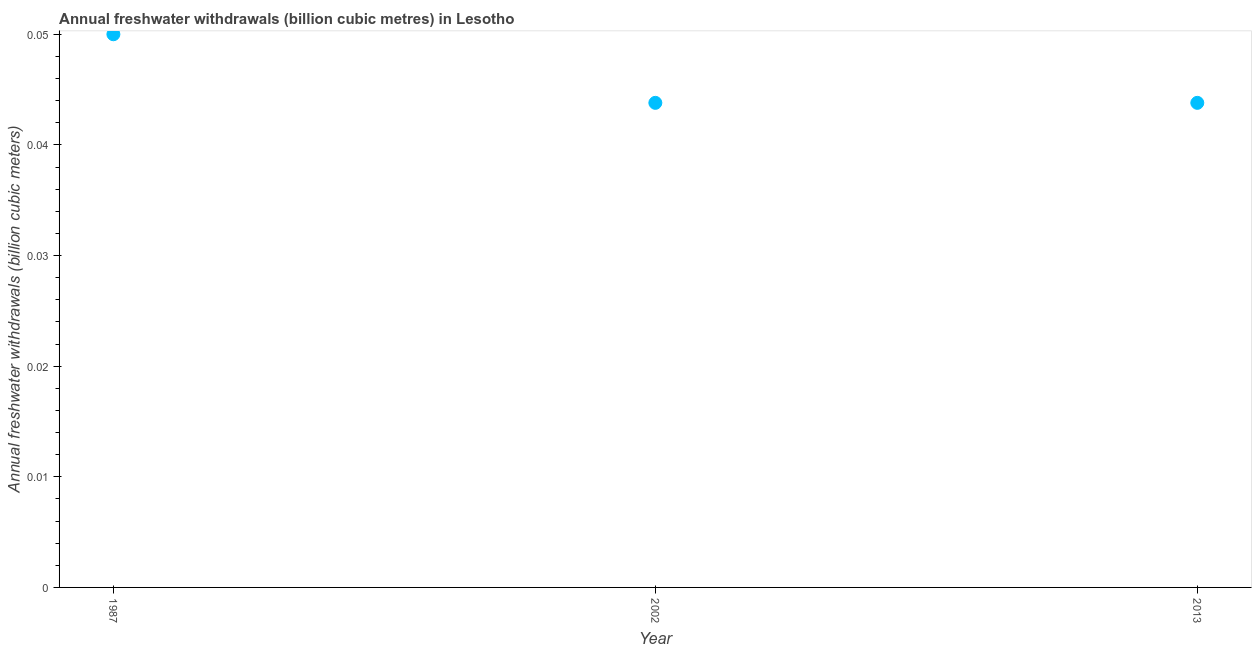What is the annual freshwater withdrawals in 2013?
Provide a succinct answer. 0.04. Across all years, what is the maximum annual freshwater withdrawals?
Keep it short and to the point. 0.05. Across all years, what is the minimum annual freshwater withdrawals?
Keep it short and to the point. 0.04. In which year was the annual freshwater withdrawals maximum?
Ensure brevity in your answer.  1987. What is the sum of the annual freshwater withdrawals?
Your response must be concise. 0.14. What is the difference between the annual freshwater withdrawals in 1987 and 2013?
Your answer should be very brief. 0.01. What is the average annual freshwater withdrawals per year?
Offer a very short reply. 0.05. What is the median annual freshwater withdrawals?
Provide a succinct answer. 0.04. What is the ratio of the annual freshwater withdrawals in 1987 to that in 2002?
Keep it short and to the point. 1.14. Is the annual freshwater withdrawals in 1987 less than that in 2013?
Your answer should be compact. No. Is the difference between the annual freshwater withdrawals in 2002 and 2013 greater than the difference between any two years?
Give a very brief answer. No. What is the difference between the highest and the second highest annual freshwater withdrawals?
Your answer should be very brief. 0.01. What is the difference between the highest and the lowest annual freshwater withdrawals?
Offer a terse response. 0.01. Does the annual freshwater withdrawals monotonically increase over the years?
Offer a very short reply. No. How many years are there in the graph?
Make the answer very short. 3. What is the title of the graph?
Your answer should be very brief. Annual freshwater withdrawals (billion cubic metres) in Lesotho. What is the label or title of the Y-axis?
Make the answer very short. Annual freshwater withdrawals (billion cubic meters). What is the Annual freshwater withdrawals (billion cubic meters) in 1987?
Your answer should be very brief. 0.05. What is the Annual freshwater withdrawals (billion cubic meters) in 2002?
Ensure brevity in your answer.  0.04. What is the Annual freshwater withdrawals (billion cubic meters) in 2013?
Offer a very short reply. 0.04. What is the difference between the Annual freshwater withdrawals (billion cubic meters) in 1987 and 2002?
Offer a very short reply. 0.01. What is the difference between the Annual freshwater withdrawals (billion cubic meters) in 1987 and 2013?
Provide a succinct answer. 0.01. What is the ratio of the Annual freshwater withdrawals (billion cubic meters) in 1987 to that in 2002?
Keep it short and to the point. 1.14. What is the ratio of the Annual freshwater withdrawals (billion cubic meters) in 1987 to that in 2013?
Ensure brevity in your answer.  1.14. 